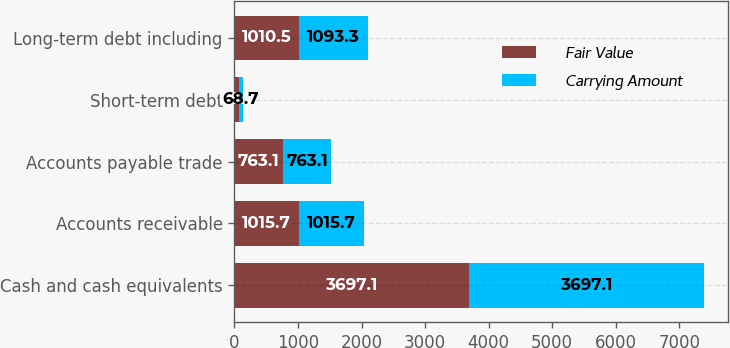Convert chart. <chart><loc_0><loc_0><loc_500><loc_500><stacked_bar_chart><ecel><fcel>Cash and cash equivalents<fcel>Accounts receivable<fcel>Accounts payable trade<fcel>Short-term debt<fcel>Long-term debt including<nl><fcel>Fair Value<fcel>3697.1<fcel>1015.7<fcel>763.1<fcel>68.7<fcel>1010.5<nl><fcel>Carrying Amount<fcel>3697.1<fcel>1015.7<fcel>763.1<fcel>68.7<fcel>1093.3<nl></chart> 